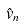Convert formula to latex. <formula><loc_0><loc_0><loc_500><loc_500>\hat { v } _ { n }</formula> 